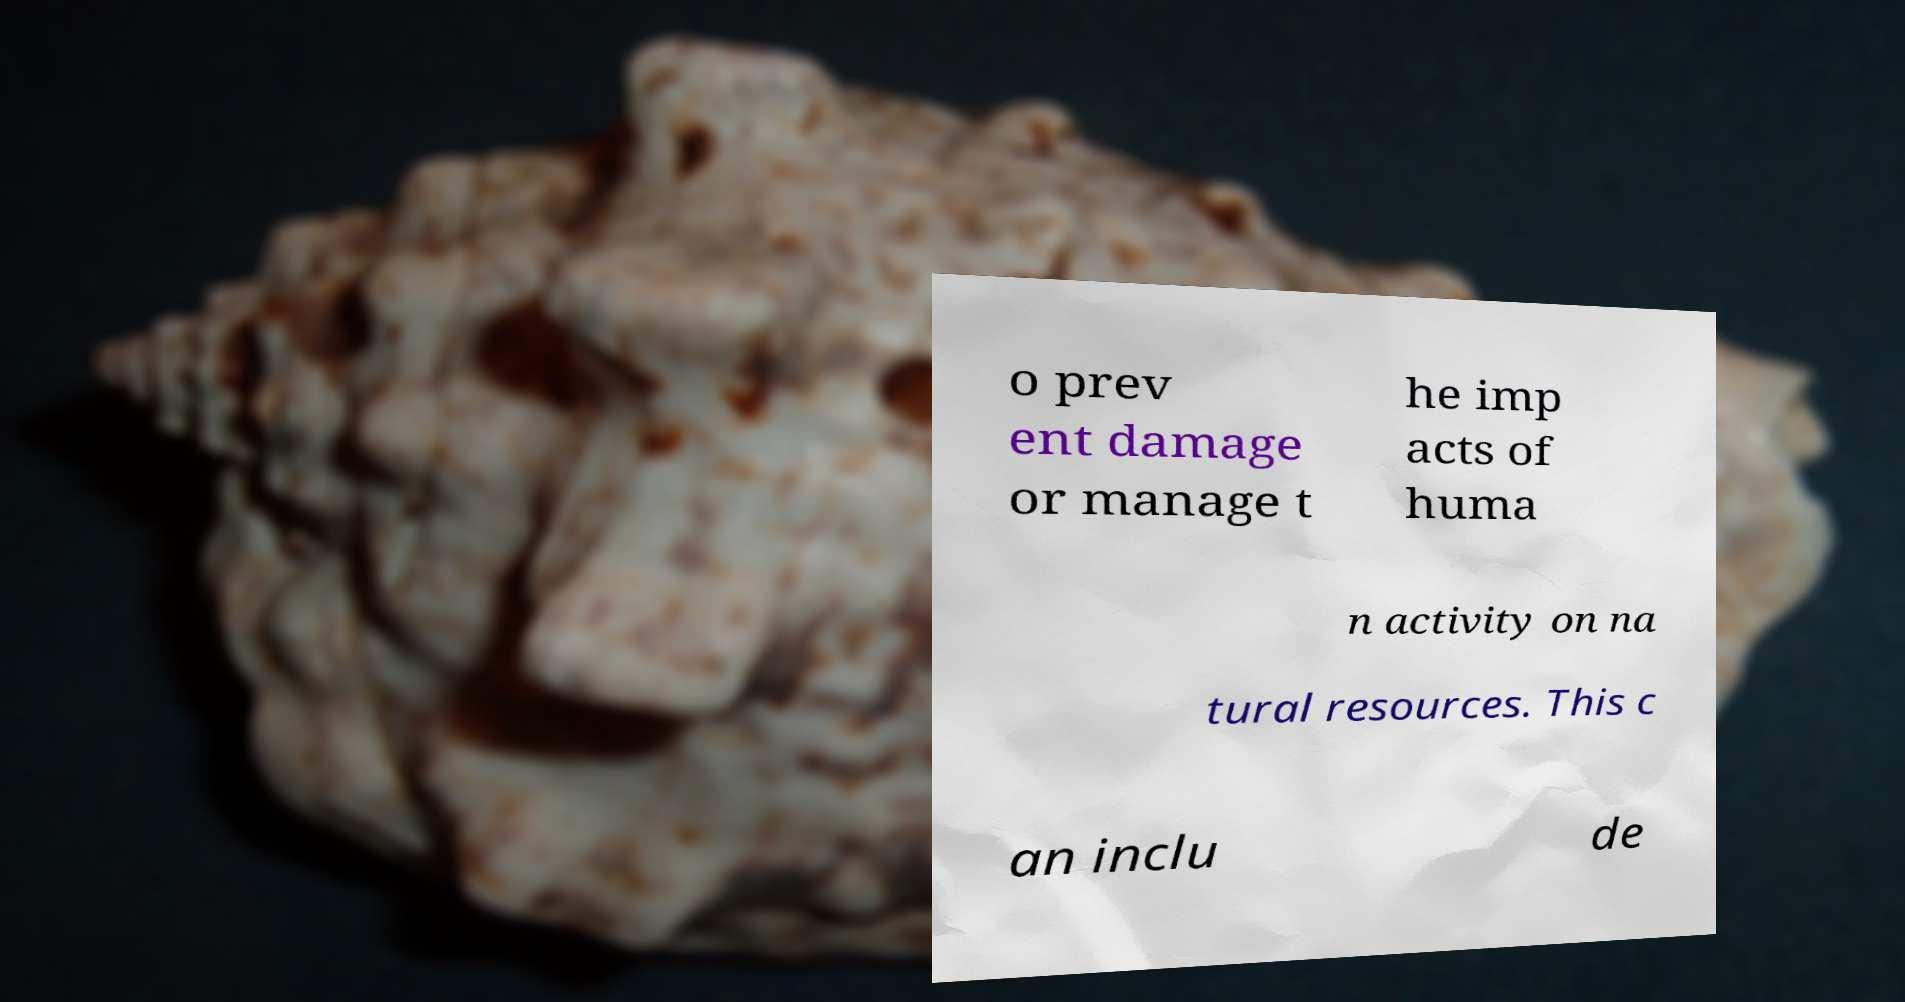Please identify and transcribe the text found in this image. o prev ent damage or manage t he imp acts of huma n activity on na tural resources. This c an inclu de 